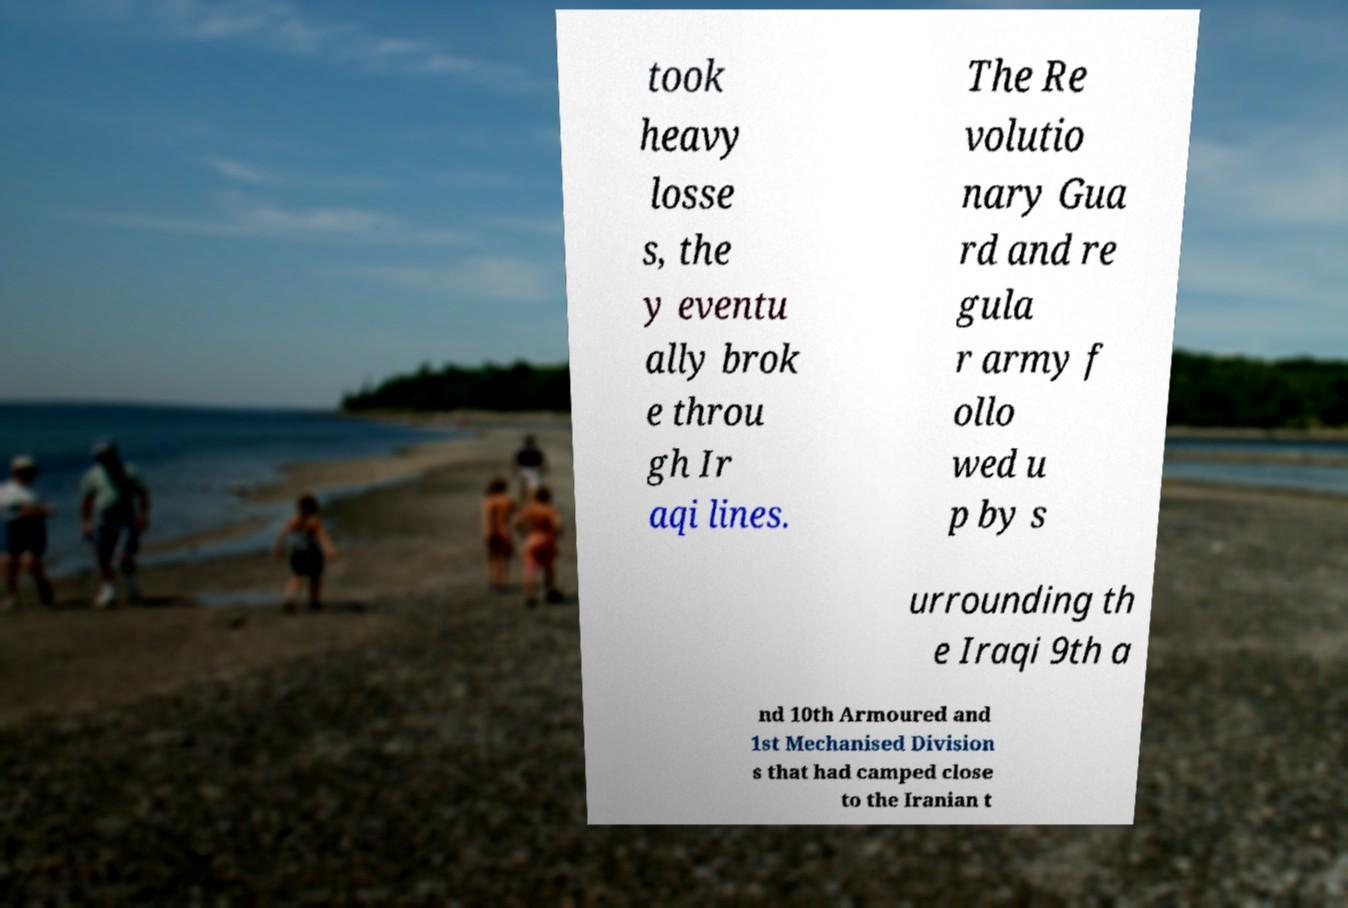Can you read and provide the text displayed in the image?This photo seems to have some interesting text. Can you extract and type it out for me? took heavy losse s, the y eventu ally brok e throu gh Ir aqi lines. The Re volutio nary Gua rd and re gula r army f ollo wed u p by s urrounding th e Iraqi 9th a nd 10th Armoured and 1st Mechanised Division s that had camped close to the Iranian t 